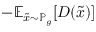<formula> <loc_0><loc_0><loc_500><loc_500>- \mathbb { E } _ { { \tilde { x } } \sim \mathbb { P } _ { g } } [ D ( { \tilde { x } } ) ]</formula> 